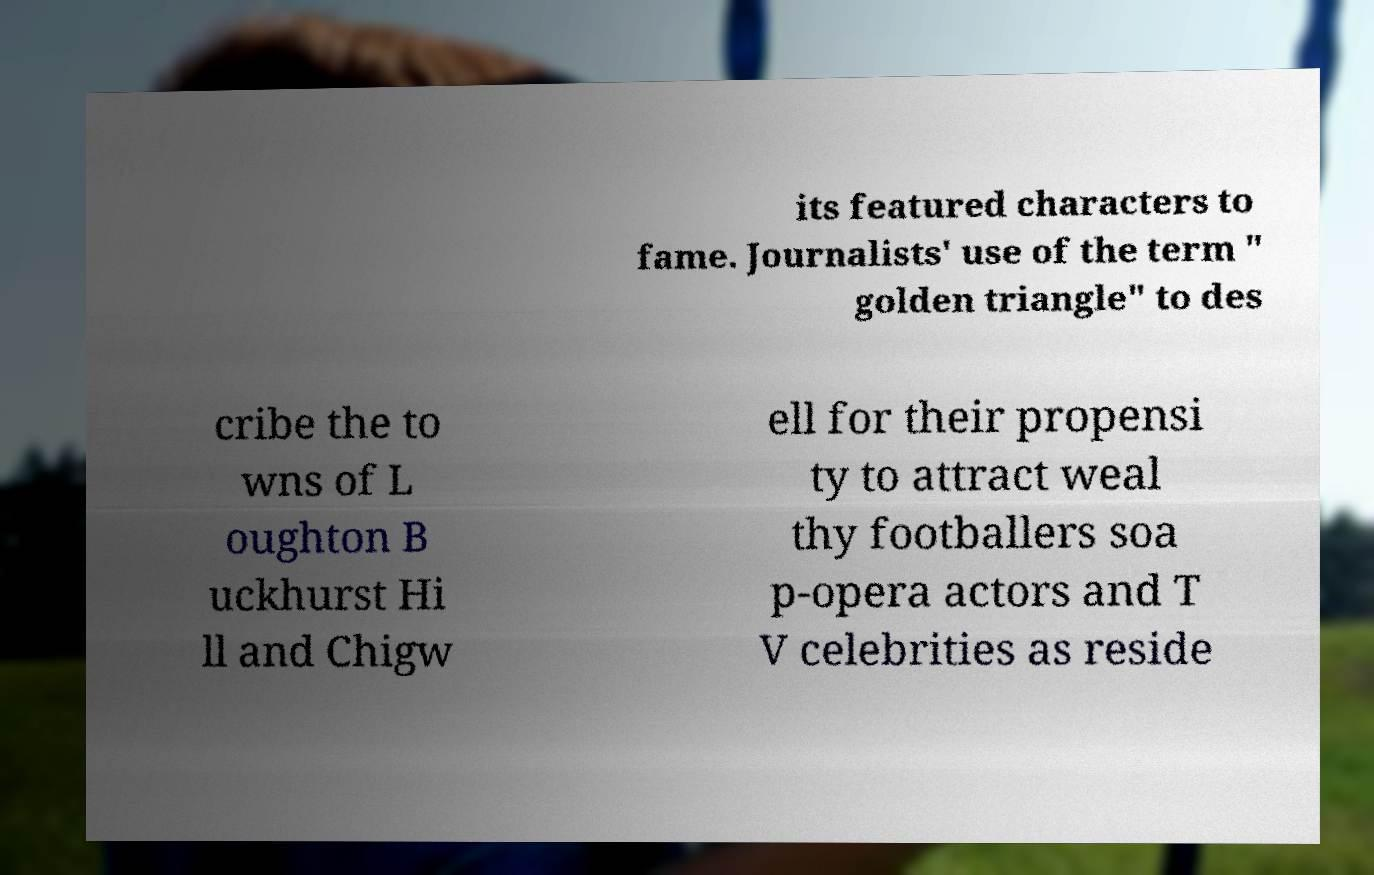Please read and relay the text visible in this image. What does it say? its featured characters to fame. Journalists' use of the term " golden triangle" to des cribe the to wns of L oughton B uckhurst Hi ll and Chigw ell for their propensi ty to attract weal thy footballers soa p-opera actors and T V celebrities as reside 